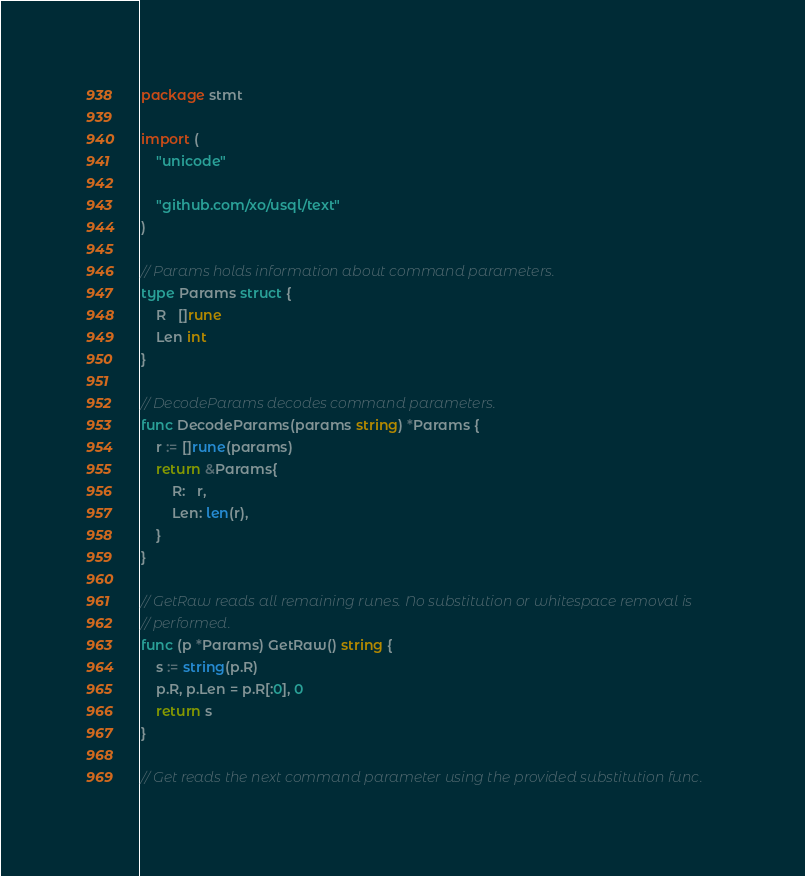Convert code to text. <code><loc_0><loc_0><loc_500><loc_500><_Go_>package stmt

import (
	"unicode"

	"github.com/xo/usql/text"
)

// Params holds information about command parameters.
type Params struct {
	R   []rune
	Len int
}

// DecodeParams decodes command parameters.
func DecodeParams(params string) *Params {
	r := []rune(params)
	return &Params{
		R:   r,
		Len: len(r),
	}
}

// GetRaw reads all remaining runes. No substitution or whitespace removal is
// performed.
func (p *Params) GetRaw() string {
	s := string(p.R)
	p.R, p.Len = p.R[:0], 0
	return s
}

// Get reads the next command parameter using the provided substitution func.</code> 